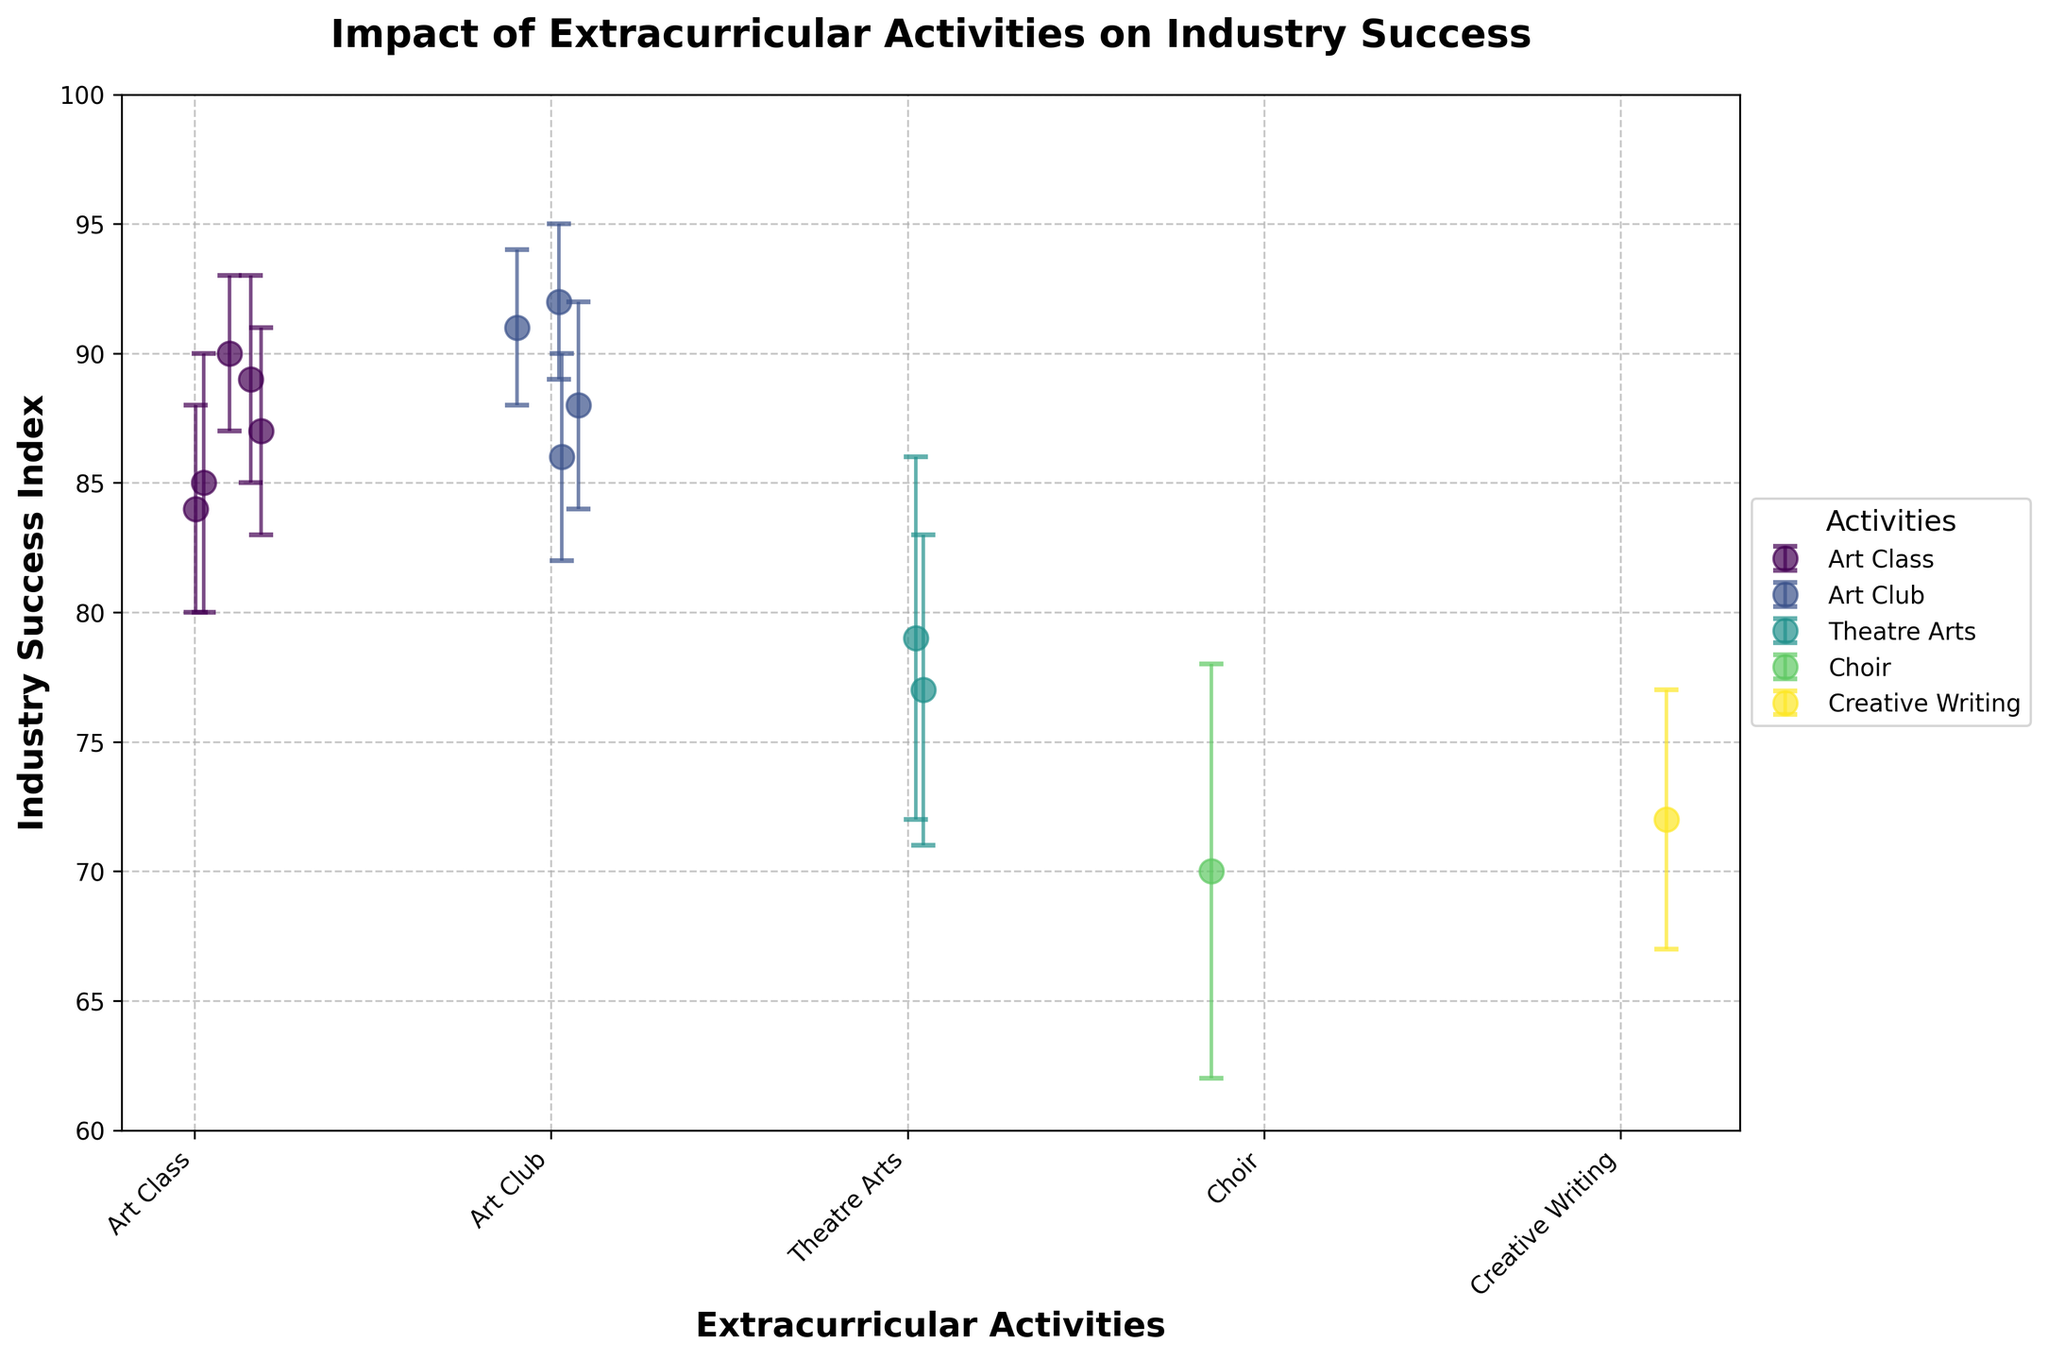What is the title of the plot? The title of the plot is located at the top of the figure and is displayed in a larger font than other text.
Answer: Impact of Extracurricular Activities on Industry Success Which extracurricular activity has the highest Industry Success Index on average? By looking at the clusters of points and their average heights, compare the central tendencies of each activity's data points and error bars. The tallest cluster represents the activity with the highest average.
Answer: Art Club How many data points are there for the 'Art Class' activity? Count the number of distinct points that are labeled under the same activity along the x-axis for 'Art Class'.
Answer: 5 What is the range of the 'Industry Success Index' for "Choir"? Identify the position of 'Choir' on the x-axis, then observe the highest and lowest y-values, including the error bars. Subtract the lowest value from the highest to get the range. Choir ranges from 62 (70 - 8) to 78 (70 + 8).
Answer: 16 Which activities have at least one student with an Industry Success Index greater than 90? Examine each cluster of points and error bars to see if any exceed the 90 mark on the y-axis. Both the central point and its error bar must be considered.
Answer: Art Class, Art Club Is the average 'Industry Success Index' higher for 'Art Club' or 'Theatre Arts'? Compare the central tendencies of the data points (and error bars) for these two activities. Art Club's cluster is consistently higher.
Answer: Art Club What is the approximate difference between the highest and lowest Industry Success Index for 'Art Club' including the error margins? Observe 'Art Club', noting the highest point plus its error margin and the lowest point minus its error margin. Then, calculate the difference. Highest: 95 (92 + 3), Lowest: 82 (86 - 4). Difference: 95 - 82 = 13.
Answer: 13 Which extracurricular activity shows the most variability in their Industry Success Index? Compare the span of error bars for all activities. The activity with the widest error bars indicates the greatest variability.
Answer: Choir How many different extracurricular activities are represented in the figure? Count the unique labels on the x-axis, which represent each activity.
Answer: 5 